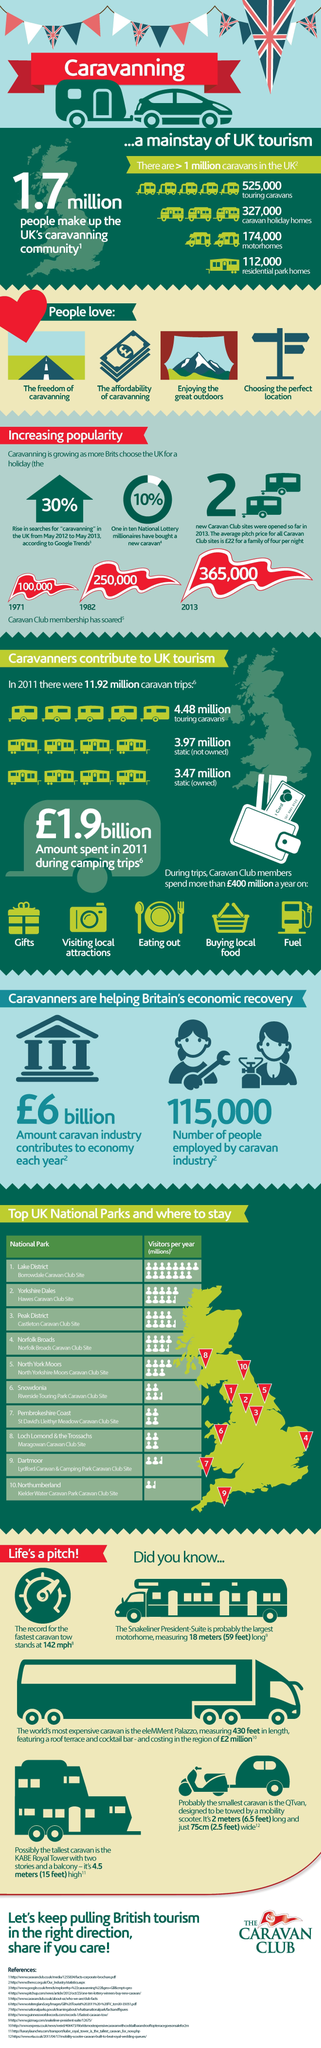Which National Park in UK has second highest no of visitors per year?
Answer the question with a short phrase. Yorkshire Dales How much static not owned caravan contributes to UK tourism ? 3.97 million Which is the second point listed under the heading "People love"? The affordability of caravanning How many Motorhomes are there in UK? 174,000 To how many people jobs were provided by the caravan industry? 115,000 How much Trip caravan contributes to UK tourism ? 4.48 million How many trip caravans are there in UK? 525,000 How many people have joined Caravan club in UK in the year 2013? 365,000 What percentage of Country's Lottery winners have taken a new caravan? 10% How many people have joined Caravan club in UK in the year 1982? 250,000 